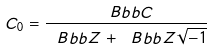<formula> <loc_0><loc_0><loc_500><loc_500>C _ { 0 } = \frac { \ B b b { C } } { \ B b b { Z } + \ B b b { Z } \sqrt { - 1 } }</formula> 